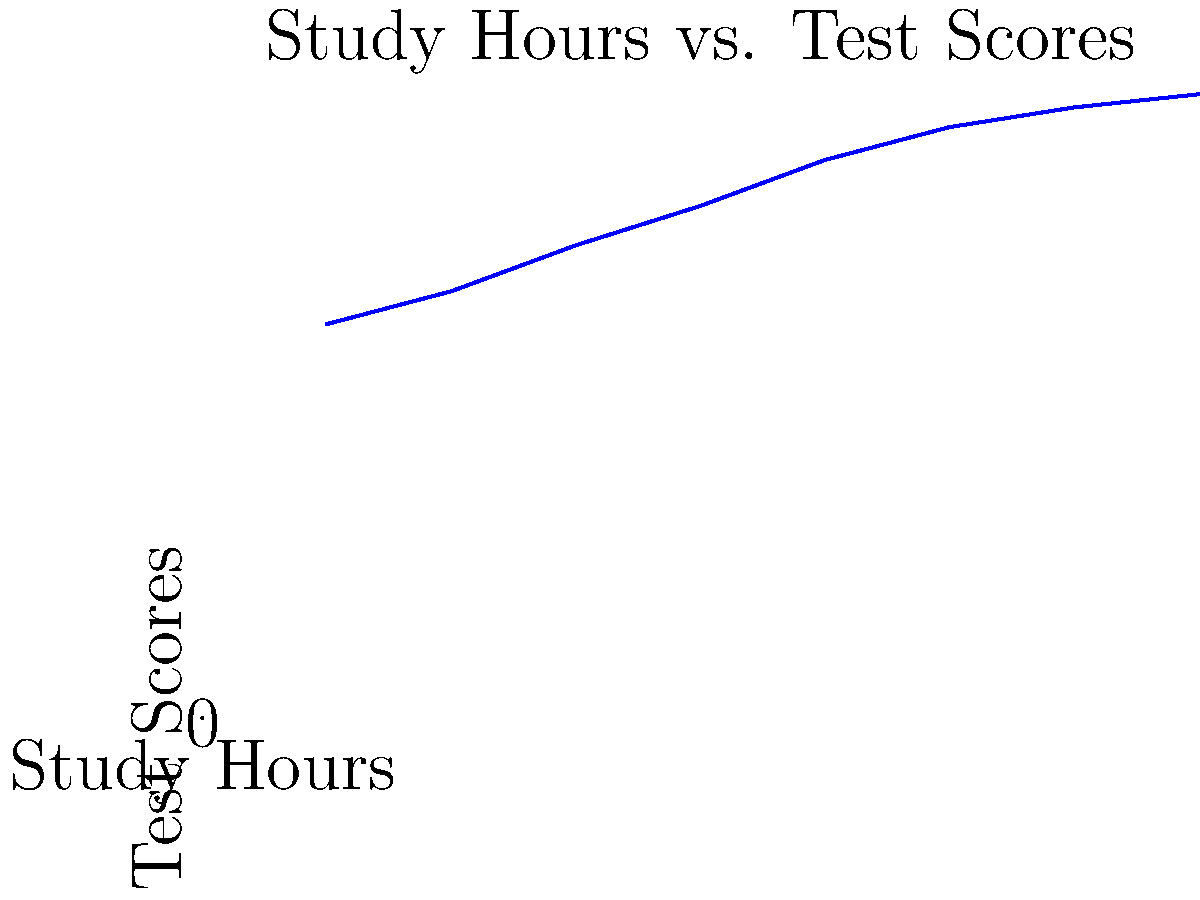Analyze the line graph depicting the correlation between study hours and test scores. What is the approximate increase in test score for each additional hour of studying, assuming a linear relationship? To find the approximate increase in test score for each additional hour of studying:

1. Identify the start and end points:
   Start: (1 hour, 60 points)
   End: (8 hours, 95 points)

2. Calculate the total change in test scores:
   $\Delta y = 95 - 60 = 35$ points

3. Calculate the total change in study hours:
   $\Delta x = 8 - 1 = 7$ hours

4. Use the slope formula to find the average increase per hour:
   $\text{Slope} = \frac{\Delta y}{\Delta x} = \frac{35}{7} = 5$ points per hour

Therefore, for each additional hour of studying, the test score increases by approximately 5 points.
Answer: 5 points per hour 